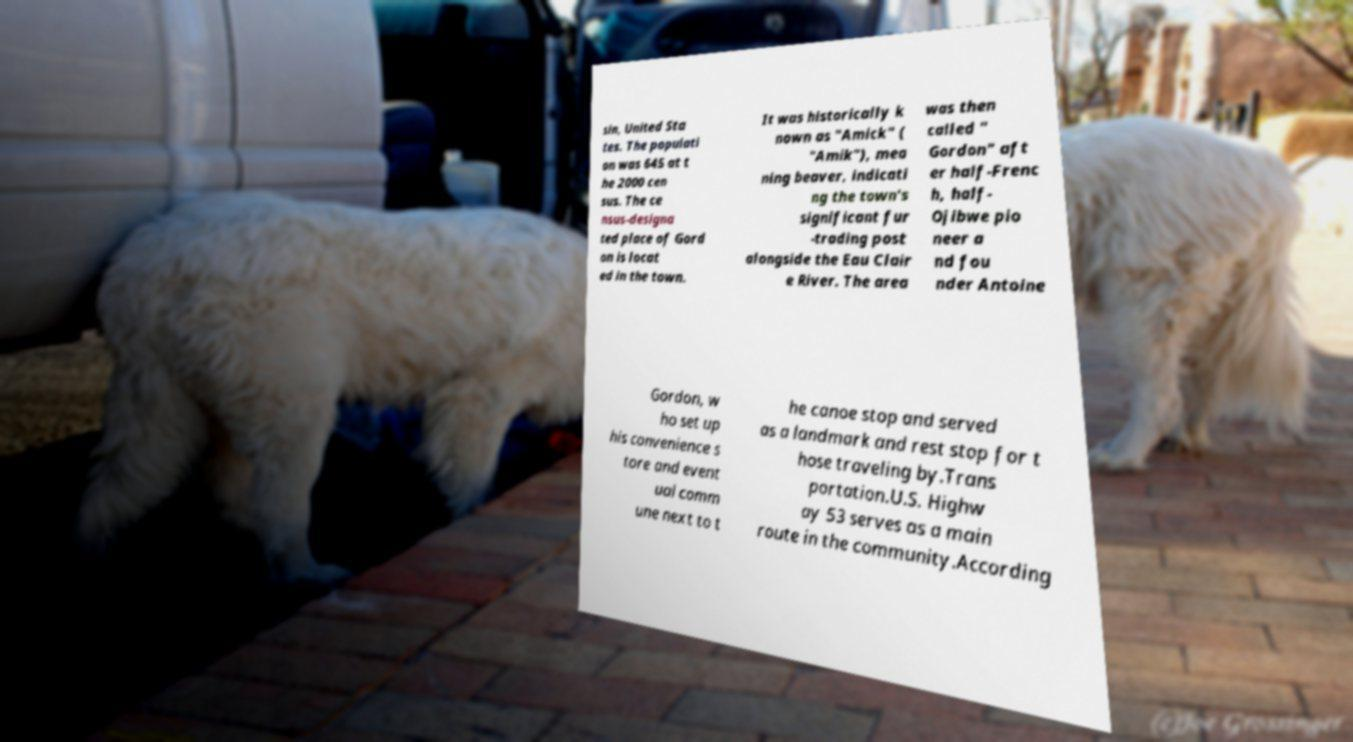Could you extract and type out the text from this image? sin, United Sta tes. The populati on was 645 at t he 2000 cen sus. The ce nsus-designa ted place of Gord on is locat ed in the town. It was historically k nown as "Amick" ( "Amik"), mea ning beaver, indicati ng the town's significant fur -trading post alongside the Eau Clair e River. The area was then called " Gordon" aft er half-Frenc h, half- Ojibwe pio neer a nd fou nder Antoine Gordon, w ho set up his convenience s tore and event ual comm une next to t he canoe stop and served as a landmark and rest stop for t hose traveling by.Trans portation.U.S. Highw ay 53 serves as a main route in the community.According 